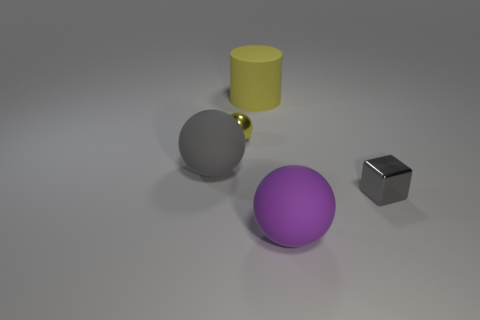Can you tell me the colors of the objects in the image? Certainly! In the image, we have objects of several colors: there's a large purple matte sphere, a smaller shiny yellow sphere, a large gray matte cylinder, and a small black matte cube. 